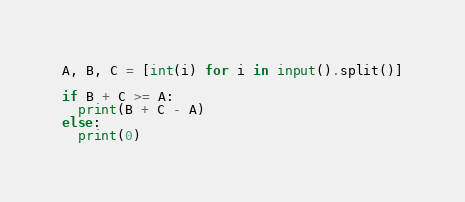<code> <loc_0><loc_0><loc_500><loc_500><_Python_>A, B, C = [int(i) for i in input().split()]

if B + C >= A:
  print(B + C - A)
else:
  print(0)</code> 